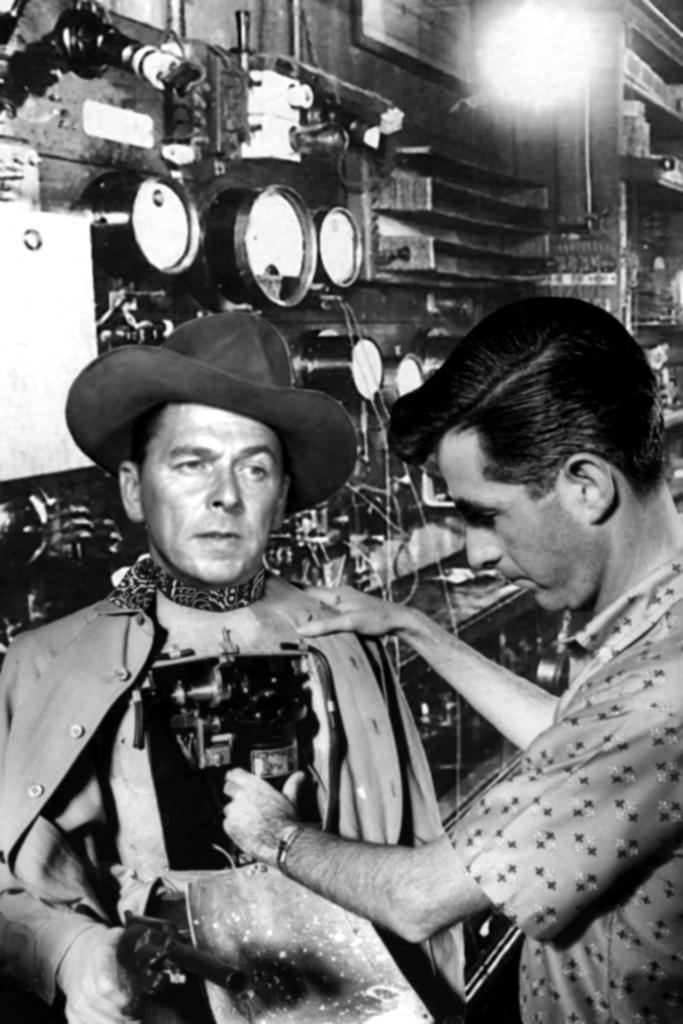Please provide a concise description of this image. This is a black and white image. Here I can see two men are standing. The man who is standing on the right side is holding an object in the hands and looking at the object. In the background, I can see few machines and wall. At the top there is a light. 